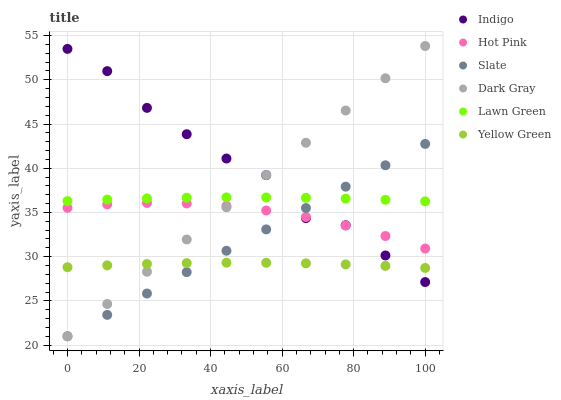Does Yellow Green have the minimum area under the curve?
Answer yes or no. Yes. Does Indigo have the maximum area under the curve?
Answer yes or no. Yes. Does Indigo have the minimum area under the curve?
Answer yes or no. No. Does Yellow Green have the maximum area under the curve?
Answer yes or no. No. Is Slate the smoothest?
Answer yes or no. Yes. Is Indigo the roughest?
Answer yes or no. Yes. Is Yellow Green the smoothest?
Answer yes or no. No. Is Yellow Green the roughest?
Answer yes or no. No. Does Slate have the lowest value?
Answer yes or no. Yes. Does Indigo have the lowest value?
Answer yes or no. No. Does Dark Gray have the highest value?
Answer yes or no. Yes. Does Indigo have the highest value?
Answer yes or no. No. Is Yellow Green less than Hot Pink?
Answer yes or no. Yes. Is Hot Pink greater than Yellow Green?
Answer yes or no. Yes. Does Slate intersect Indigo?
Answer yes or no. Yes. Is Slate less than Indigo?
Answer yes or no. No. Is Slate greater than Indigo?
Answer yes or no. No. Does Yellow Green intersect Hot Pink?
Answer yes or no. No. 